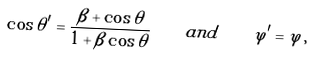Convert formula to latex. <formula><loc_0><loc_0><loc_500><loc_500>\cos \theta ^ { \prime } = \frac { \beta + \cos \theta } { 1 + \beta \cos \theta } \quad a n d \quad \varphi ^ { \prime } = \varphi \, ,</formula> 